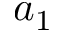<formula> <loc_0><loc_0><loc_500><loc_500>a _ { 1 }</formula> 